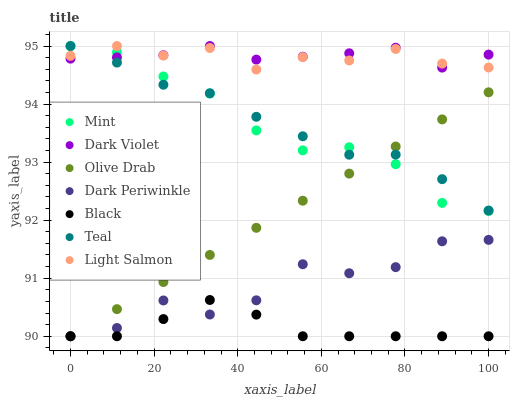Does Black have the minimum area under the curve?
Answer yes or no. Yes. Does Dark Violet have the maximum area under the curve?
Answer yes or no. Yes. Does Dark Violet have the minimum area under the curve?
Answer yes or no. No. Does Black have the maximum area under the curve?
Answer yes or no. No. Is Olive Drab the smoothest?
Answer yes or no. Yes. Is Dark Periwinkle the roughest?
Answer yes or no. Yes. Is Dark Violet the smoothest?
Answer yes or no. No. Is Dark Violet the roughest?
Answer yes or no. No. Does Black have the lowest value?
Answer yes or no. Yes. Does Dark Violet have the lowest value?
Answer yes or no. No. Does Teal have the highest value?
Answer yes or no. Yes. Does Black have the highest value?
Answer yes or no. No. Is Dark Periwinkle less than Teal?
Answer yes or no. Yes. Is Teal greater than Black?
Answer yes or no. Yes. Does Teal intersect Light Salmon?
Answer yes or no. Yes. Is Teal less than Light Salmon?
Answer yes or no. No. Is Teal greater than Light Salmon?
Answer yes or no. No. Does Dark Periwinkle intersect Teal?
Answer yes or no. No. 